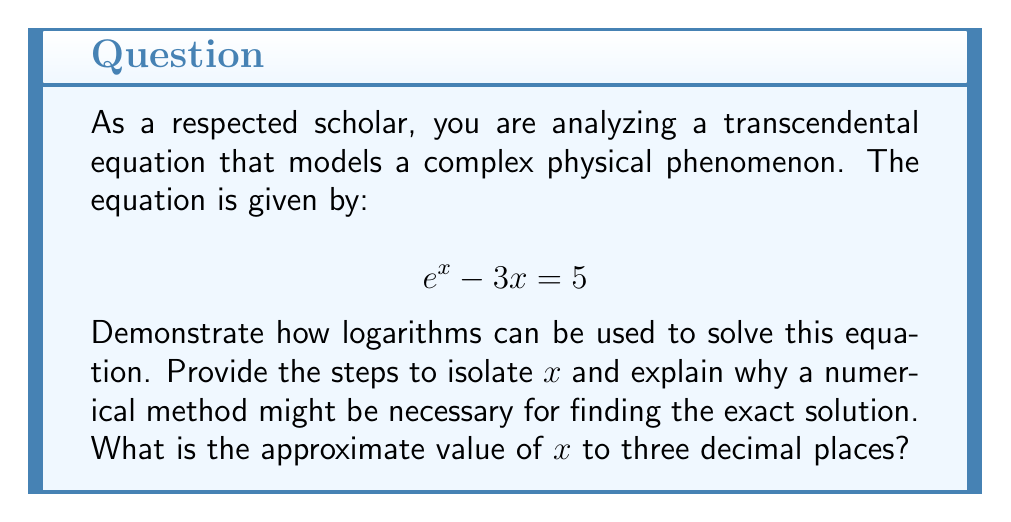Provide a solution to this math problem. To solve this transcendental equation using logarithms, we follow these steps:

1) First, we rearrange the equation to isolate $e^x$ on one side:
   $$ e^x = 3x + 5 $$

2) Now, we apply the natural logarithm (ln) to both sides:
   $$ \ln(e^x) = \ln(3x + 5) $$

3) Using the logarithm property $\ln(e^x) = x$, we simplify the left side:
   $$ x = \ln(3x + 5) $$

At this point, we've successfully used logarithms to isolate x on one side of the equation. However, x still appears on both sides, making it a transcendental equation that cannot be solved algebraically.

To find the solution, we need to use a numerical method such as the Newton-Raphson method or bisection method. This is because transcendental equations often don't have closed-form solutions.

Using a graphing calculator or computer software, we can approximate the solution. The equation $x = \ln(3x + 5)$ and $y = x$ intersect at the solution point.

Applying the Newton-Raphson method with an initial guess of x = 2:

$$ x_{n+1} = x_n - \frac{f(x_n)}{f'(x_n)} $$

Where $f(x) = x - \ln(3x + 5)$ and $f'(x) = 1 - \frac{3}{3x + 5}$

After several iterations, we converge to the solution.
Answer: The approximate solution to three decimal places is $x \approx 2.389$. 